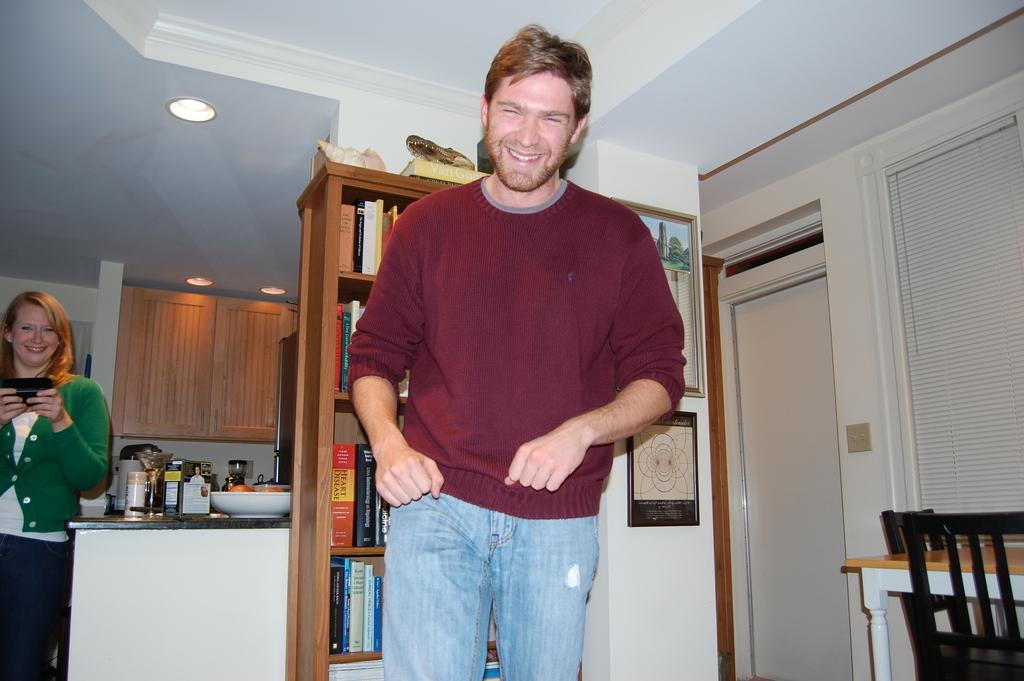Describe this image in one or two sentences. In this image we can see two persons standing. In the center of the image we can see group of books placed in a rack. On the left side of the image we can see a woman holding a mobile in her hand, we can also see some objects and a bowl placed on the counter top. On the right side of the image we can see chairs, table, window and a door. In the background, we can see cupboard and some lights on the ceiling. 